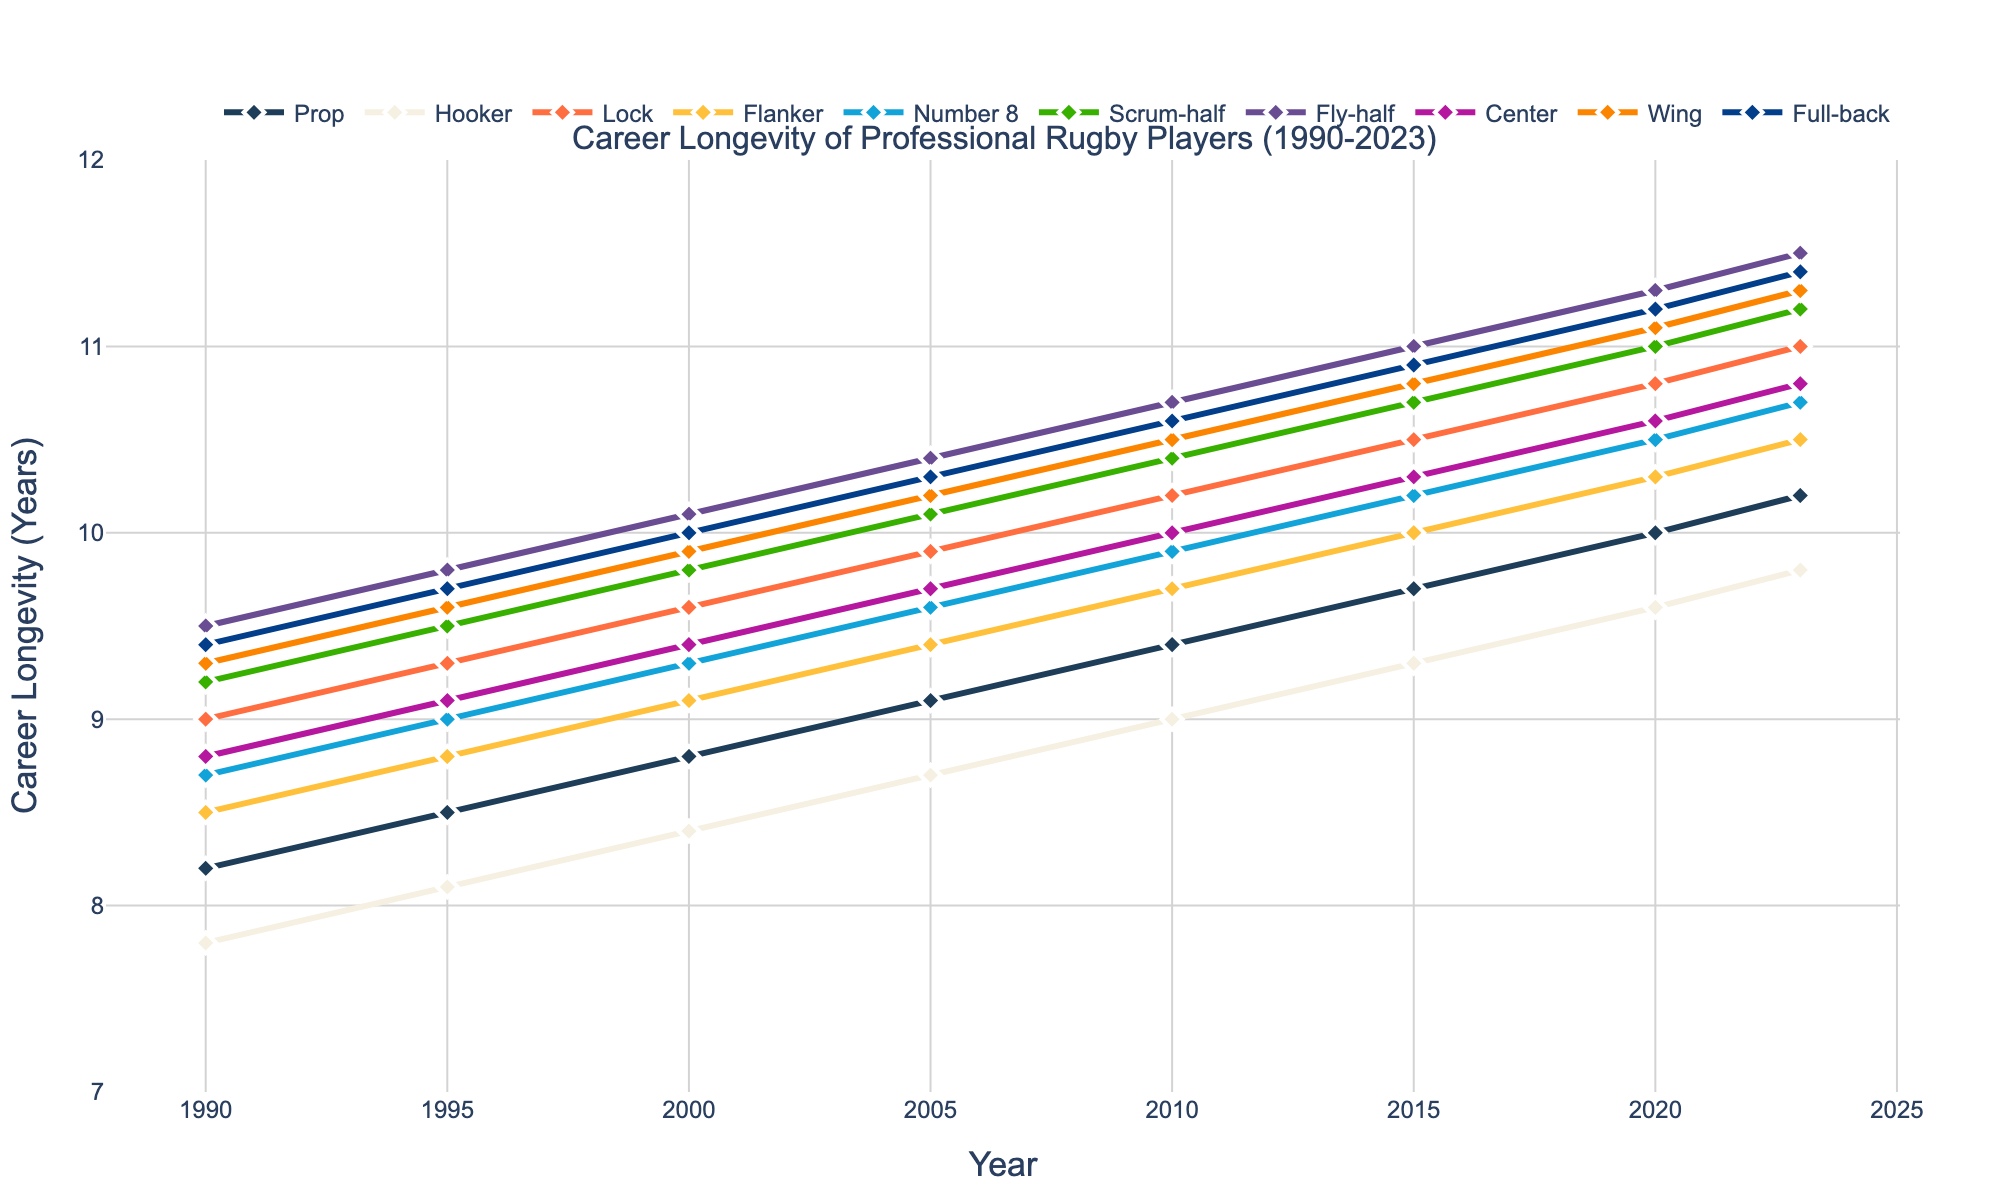What position has the longest career longevity in 2023? Look at the chart for the longest line in 2023, which represents the career longevity of players by position. Identify the highest point in 2023, which corresponds to the Fly-half
Answer: Fly-half How much did the career longevity for Props change from 1990 to 2023? Look at the career longevity value for Props in 1990 and 2023. Subtract the 1990 value from the 2023 value: 10.2 - 8.2
Answer: 2.0 Which position showed the greatest increase in career longevity from 1990 to 2023? Calculate the difference in career longevity from 1990 to 2023 for all positions. The position with the highest increase is the Fly-half (11.5 - 9.5 = 2.0)
Answer: Fly-half In 2020, were Wingers' career longevity greater than Centers? Compare the career longevity values of Wingers and Centers in 2020. Winger: 11.1; Center: 10.6. Since 11.1 > 10.6, the answer is yes
Answer: Yes What is the average career longevity of Locks over the selected years? Sum the career longevity values of Locks from 1990 to 2023 and divide by the number of years: (9.0 + 9.3 + 9.6 + 9.9 + 10.2 + 10.5 + 10.8 + 11.0) / 8 = 10.0
Answer: 10.0 Which position had the smallest career longevity in 1995? Identify the lowest point in the chart for 1995 across all positions. The lowest value is for Hookers
Answer: Hooker In what year did Fly-halves surpass Wings in career longevity? Examine the intersection points of Fly-halves and Wings on the chart. Fly-halves surpassed Wings between 2015 and 2020. Compare the longevity values: 2015: Fly-half (11.0), Wing (10.8); 2020: Fly-half (11.3), Wing (11.1). The intersection occurred between these values
Answer: 2020 How has the career longevity of Hookers changed relative to Scrum-halves from 1990 to 2023? Find the career longevity values for Hookers and Scrum-halves in 1990 and 2023 to compare their differences. Hookers increased by 2.0 years (9.8 - 7.8), and Scrum-halves increased by 2.0 years (11.2 - 9.2). Both experienced the same increase
Answer: Same increase Which positions had their career longevity exceed 11 years in 2023? Look at the career longevity values in 2023. Positions with values over 11 years are Fly-half (11.5), Wing (11.3), Full-back (11.4), and Scrum-half (11.2)
Answer: Fly-half, Wing, Full-back, Scrum-half 